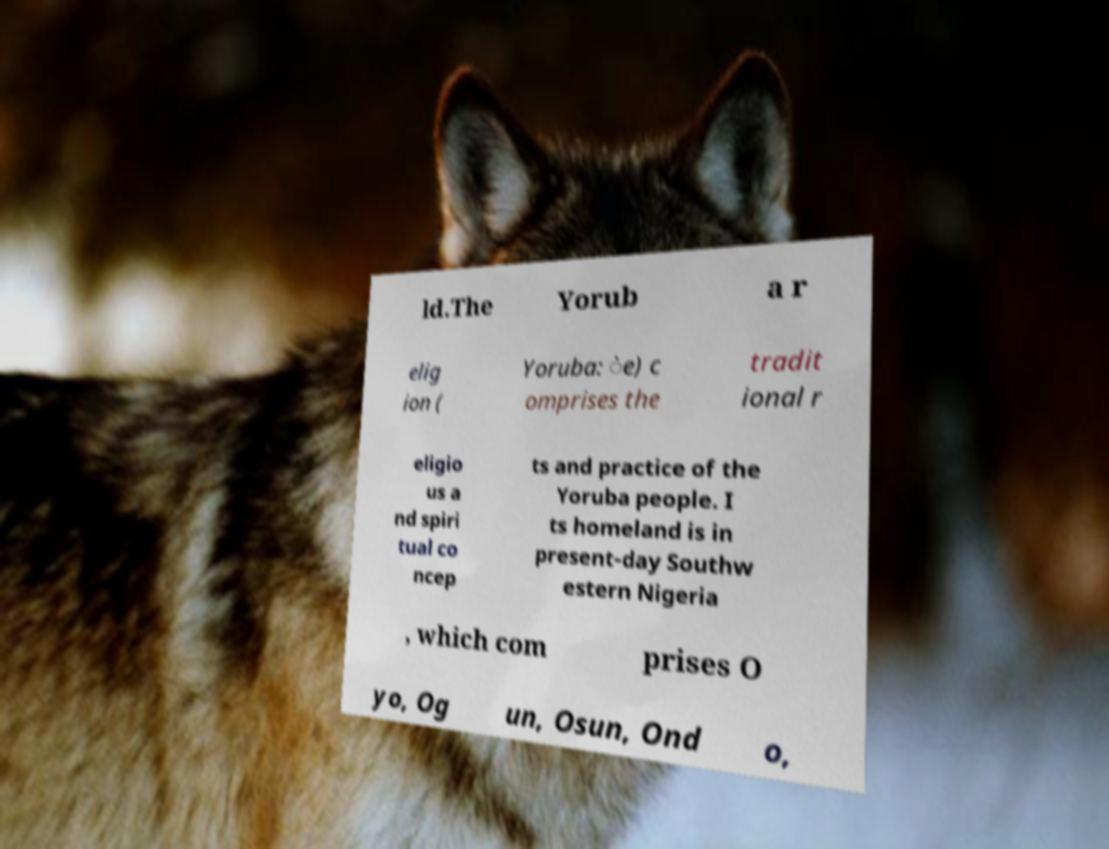Please read and relay the text visible in this image. What does it say? ld.The Yorub a r elig ion ( Yoruba: ̀e) c omprises the tradit ional r eligio us a nd spiri tual co ncep ts and practice of the Yoruba people. I ts homeland is in present-day Southw estern Nigeria , which com prises O yo, Og un, Osun, Ond o, 